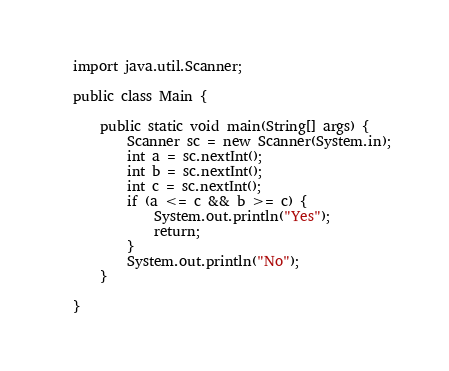Convert code to text. <code><loc_0><loc_0><loc_500><loc_500><_Java_>import java.util.Scanner;

public class Main {

    public static void main(String[] args) {
        Scanner sc = new Scanner(System.in);
        int a = sc.nextInt();
        int b = sc.nextInt();
        int c = sc.nextInt();
        if (a <= c && b >= c) {
            System.out.println("Yes");
            return;
        }
        System.out.println("No");
    }

}
</code> 